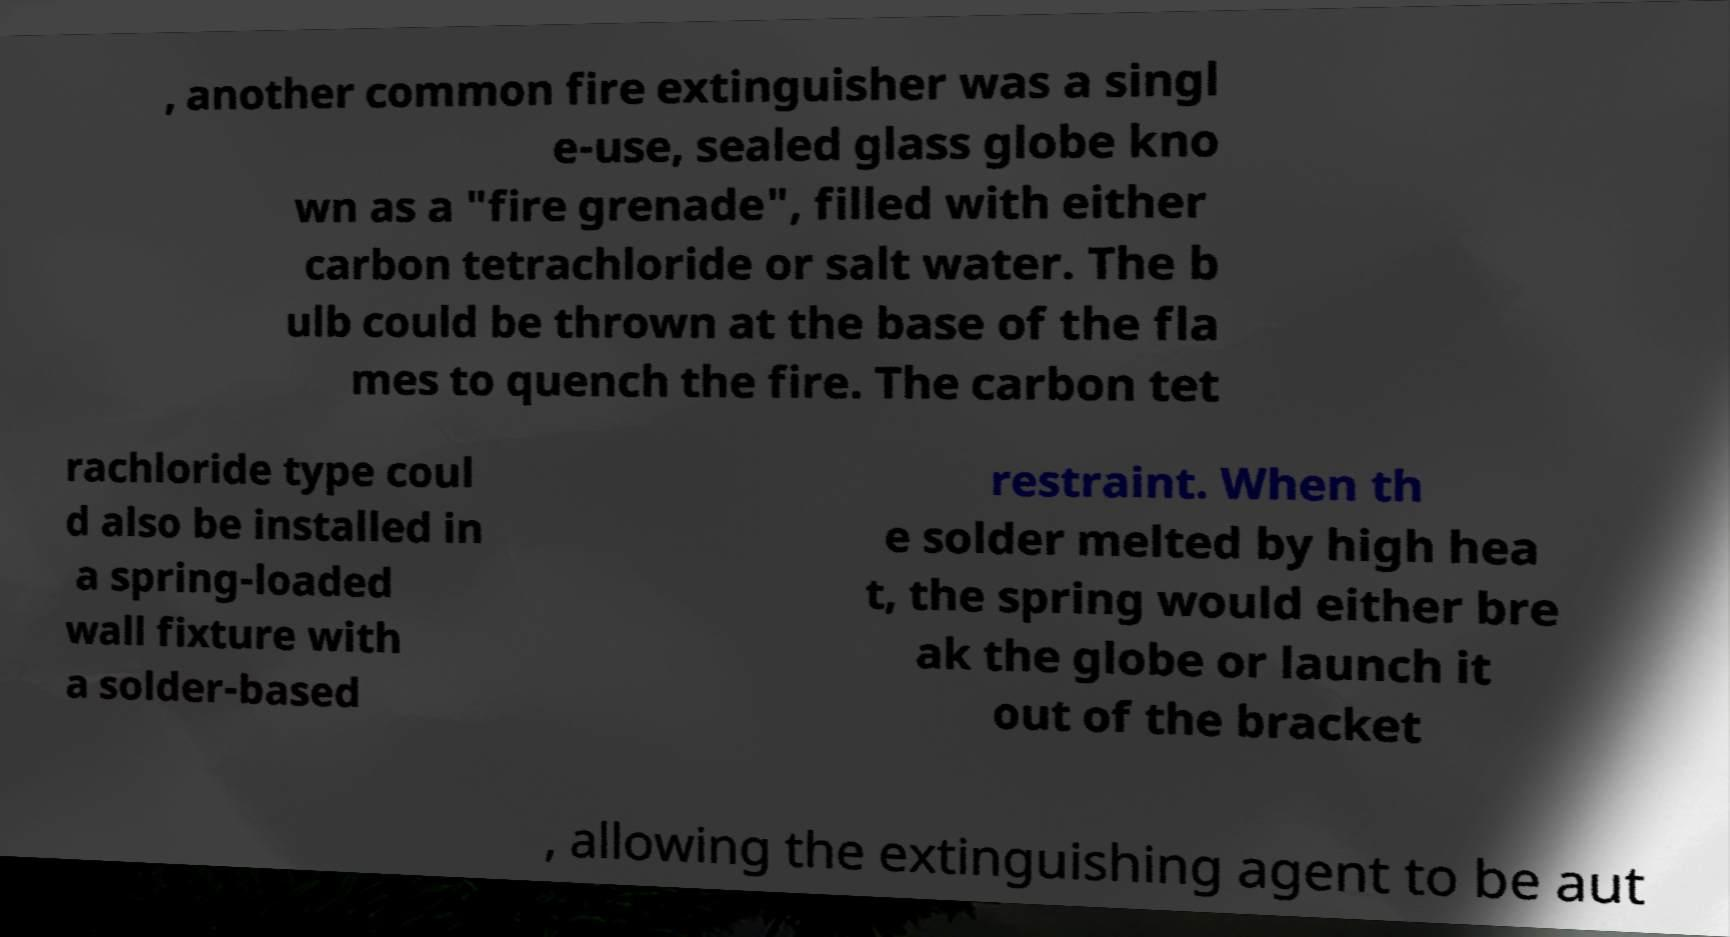Could you extract and type out the text from this image? , another common fire extinguisher was a singl e-use, sealed glass globe kno wn as a "fire grenade", filled with either carbon tetrachloride or salt water. The b ulb could be thrown at the base of the fla mes to quench the fire. The carbon tet rachloride type coul d also be installed in a spring-loaded wall fixture with a solder-based restraint. When th e solder melted by high hea t, the spring would either bre ak the globe or launch it out of the bracket , allowing the extinguishing agent to be aut 